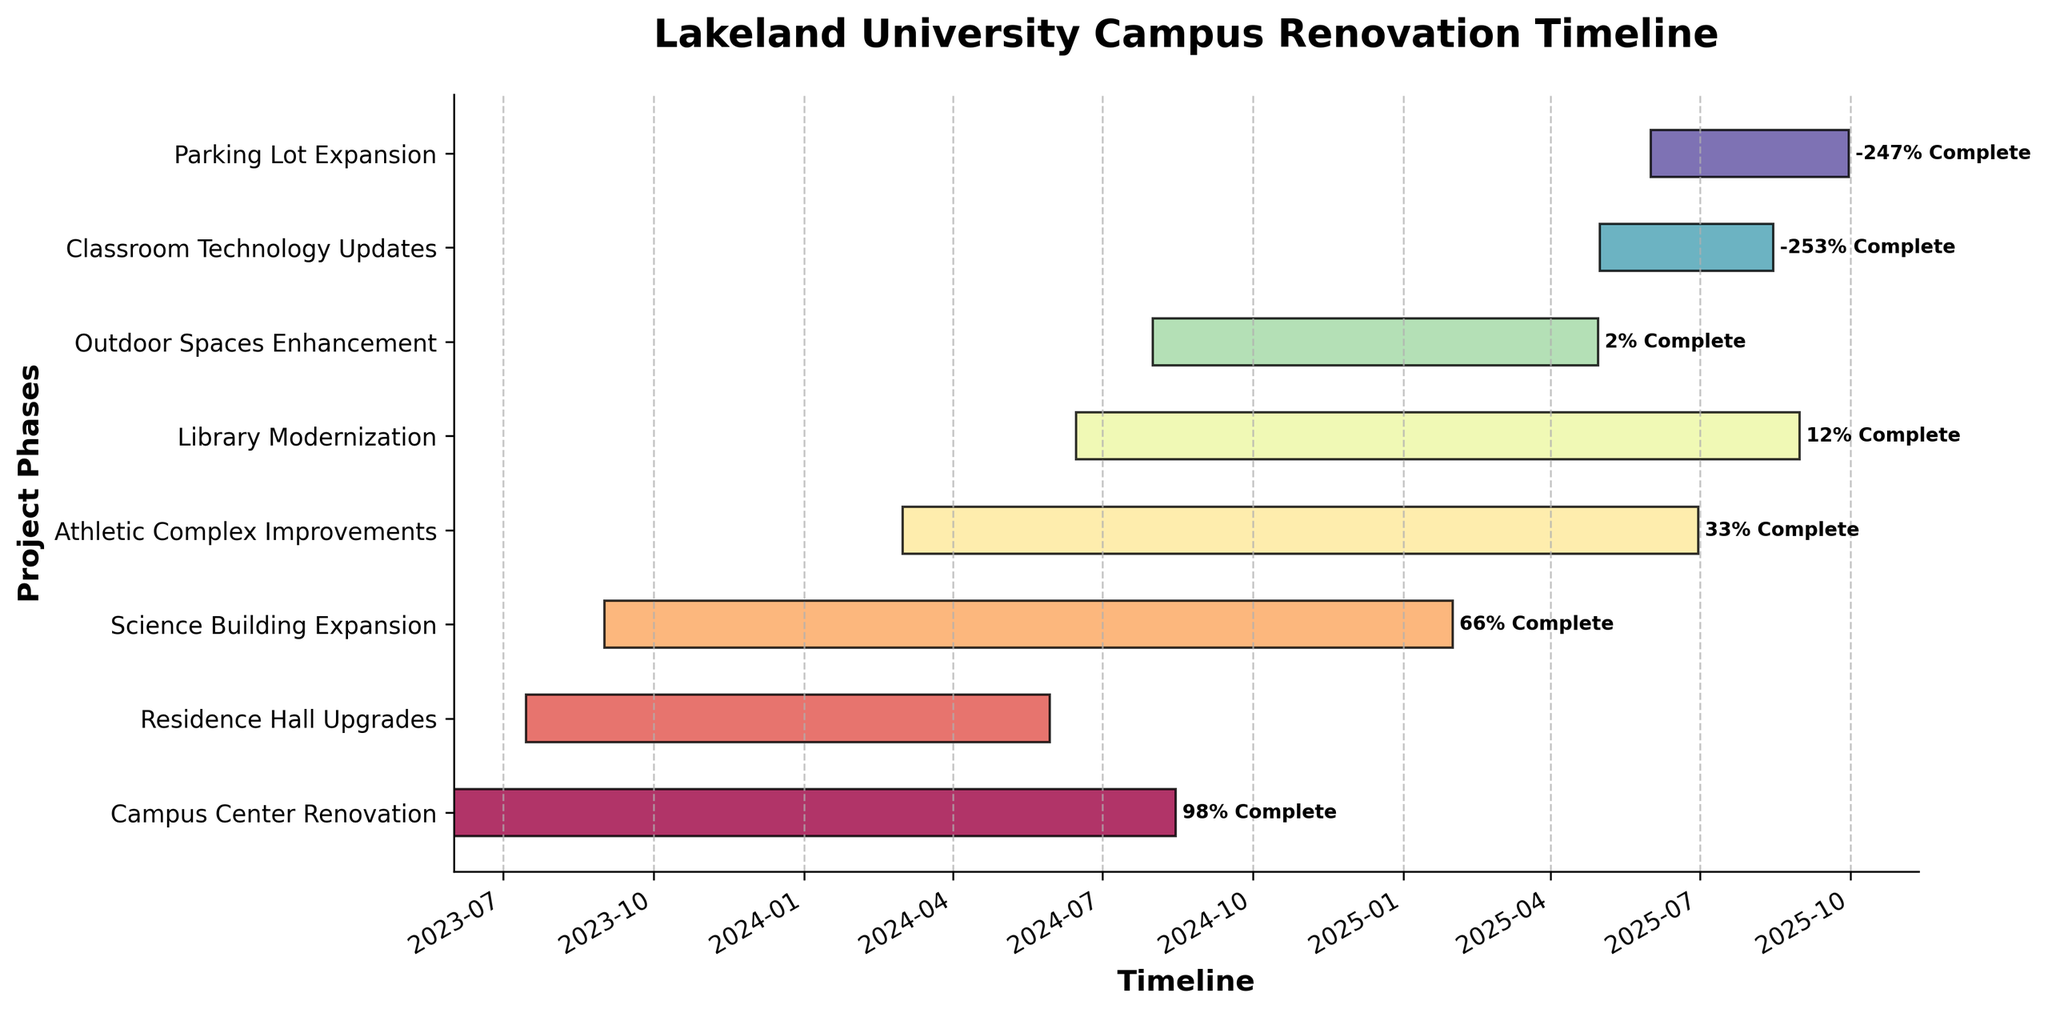What's the title of the project? The title can be found at the top of the Gantt Chart as the main heading.
Answer: Lakeland University Campus Renovation Timeline Which project phase starts first? To answer this, look for the earliest start date in the chart. The earliest date is June 1, 2023, for the "Campus Center Renovation".
Answer: Campus Center Renovation What is the duration of the Science Building Expansion phase? The duration can be calculated by subtracting the start date from the end date for the Science Building Expansion. It starts on September 1, 2023, and ends on January 31, 2025.
Answer: 517 days Which project phase will be completed last? To find this, look for the latest end date in the chart, which is for the Parking Lot Expansion ending on September 30, 2025.
Answer: Parking Lot Expansion Which two phases will be active at the same time starting from March 1, 2024? Check the start dates of the phases and see which ones are active during March 2024. Both "Athletic Complex Improvements" and "Science Building Expansion" overlap during this time.
Answer: Athletic Complex Improvements and Science Building Expansion How long will it take to upgrade the Residence Hall? Check the start and end dates for the Residence Hall Upgrades. It starts on July 15, 2023, and ends on May 30, 2024.
Answer: 320 days Are there any project phases overlapping the Library Modernization? Compare start and end dates of the Library Modernization with other phases. It overlaps with Athletic Complex Improvements, Outdoor Spaces Enhancement, Classroom Technology Updates, and Parking Lot Expansion.
Answer: Yes Which project phase has the shortest duration? By calculating the durations and comparing, you'll find that the "Classroom Technology Updates" has the shortest duration starting from May 1, 2025, ending on August 15, 2025.
Answer: Classroom Technology Updates How many project phases are expected to be completed by the end of 2024? Look at the end dates of all the project phases and count how many are before December 31, 2024.
Answer: Three phases What is the total duration of the projects if they were completed sequentially? Sum up the durations of all the phases for a sequential completion.
Answer: 1,277 days 